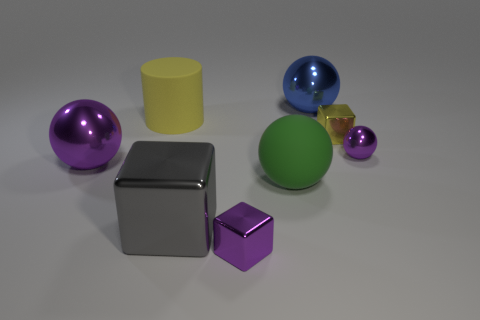How many other objects are there of the same color as the small shiny ball?
Offer a very short reply. 2. What number of tiny yellow blocks are made of the same material as the big purple thing?
Ensure brevity in your answer.  1. Is the color of the big metallic sphere that is to the left of the blue metal ball the same as the big cube?
Provide a succinct answer. No. What number of green objects are either metal balls or objects?
Ensure brevity in your answer.  1. Are there any other things that are made of the same material as the tiny ball?
Provide a short and direct response. Yes. Does the purple sphere right of the big rubber cylinder have the same material as the yellow block?
Your response must be concise. Yes. How many things are either tiny brown metal objects or tiny metal cubes behind the big purple metal thing?
Your response must be concise. 1. There is a big metallic sphere that is behind the big purple ball in front of the tiny shiny sphere; what number of objects are to the left of it?
Your answer should be compact. 5. Do the large rubber object that is behind the tiny yellow object and the yellow metal thing have the same shape?
Make the answer very short. No. There is a shiny ball that is behind the small yellow block; is there a tiny yellow shiny object on the right side of it?
Your answer should be very brief. Yes. 